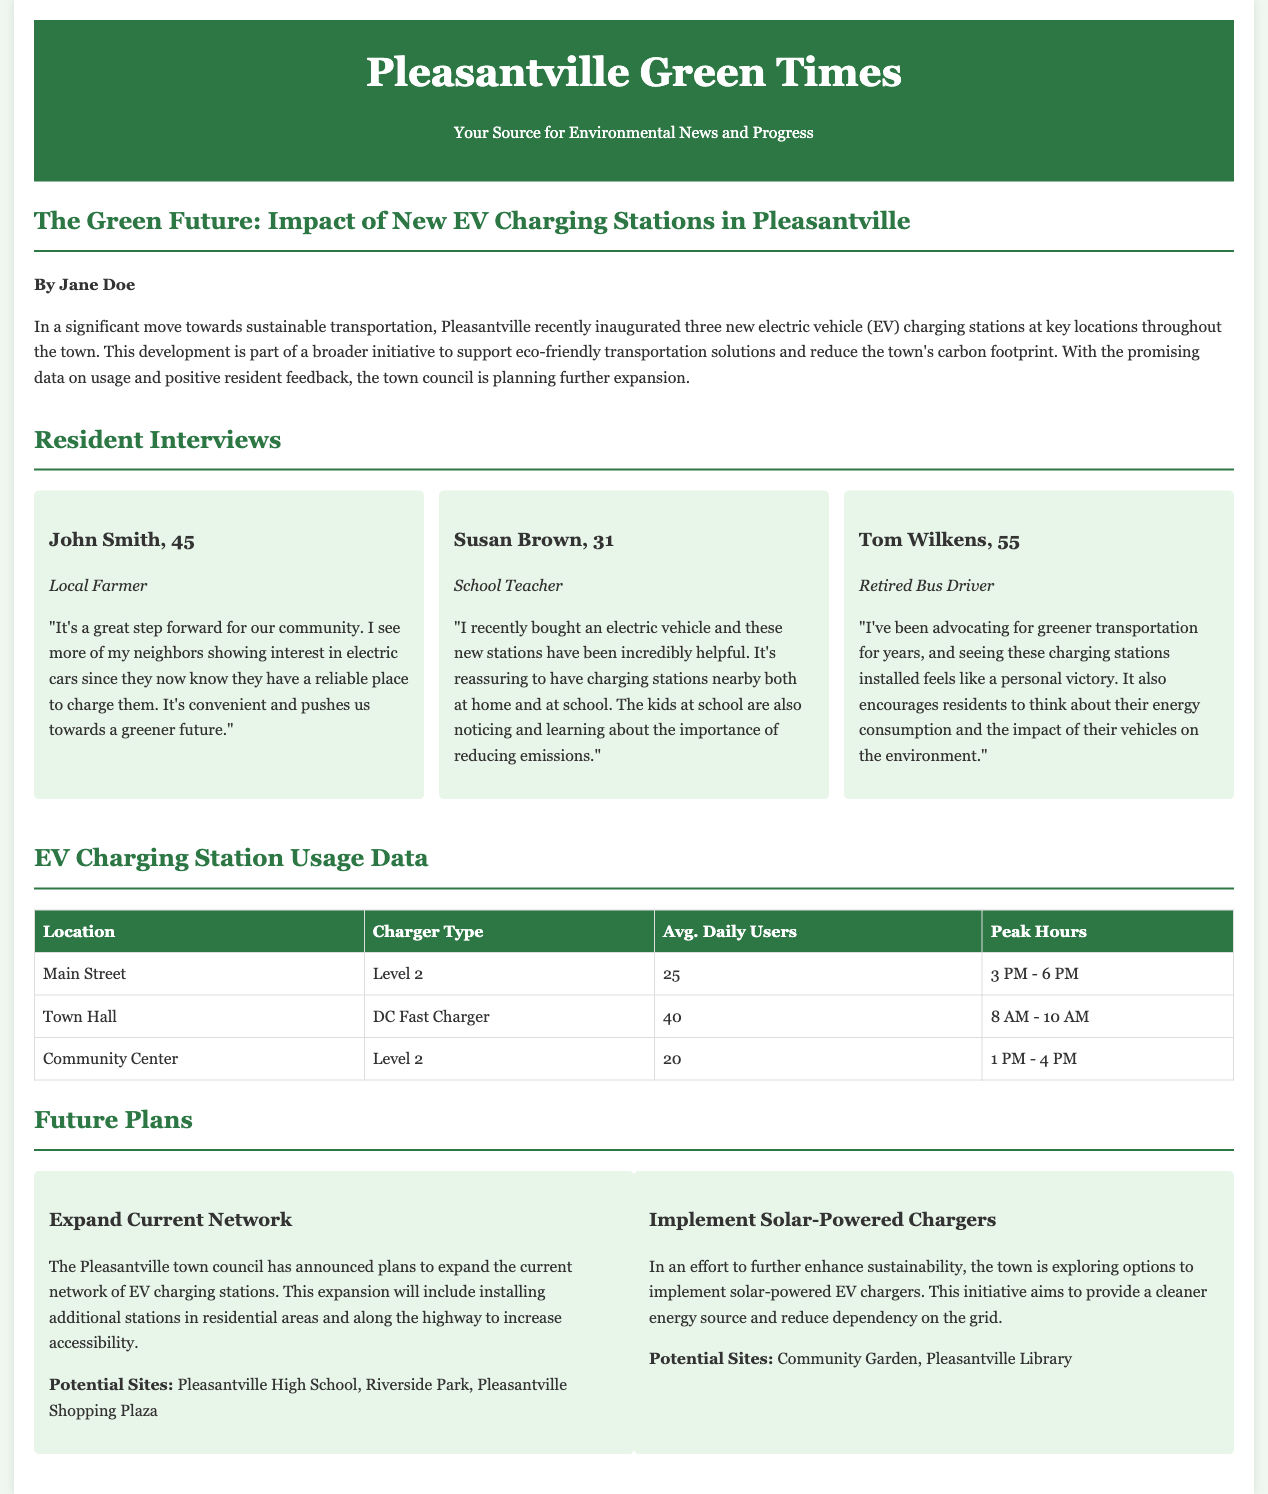what is the title of the article? The title of the article is given at the beginning of the article section.
Answer: The Green Future: Impact of New EV Charging Stations in Pleasantville who is the author of the article? The author's name is mentioned below the title in the article's introduction.
Answer: Jane Doe how many new electric vehicle charging stations were inaugurated? The number of new charging stations is explicitly stated in the introductory paragraph of the article.
Answer: three which location has the highest average daily users? The usage data table specifies the average daily users for each charging station, allowing for comparison.
Answer: Town Hall what type of charger is located at Main Street? The charging station type is listed in the data table for each location.
Answer: Level 2 what is one of the potential sites for expanding the EV charging network? The future plans section presents several potential sites for expansion as part of the town's initiatives.
Answer: Pleasantville High School what are the peak hours for the Town Hall charging station? The peak hours are provided in the usage data table, detailing when each charger experiences the most traffic.
Answer: 8 AM - 10 AM who expressed support for greener transportation? The resident interviews include multiple perspectives, highlighting sentiments about EVs and charging stations.
Answer: Tom Wilkens what initiative is the town exploring to enhance sustainability? The future plans section outlines specific initiatives, detailing efforts to implement new technologies.
Answer: Solar-Powered Chargers 